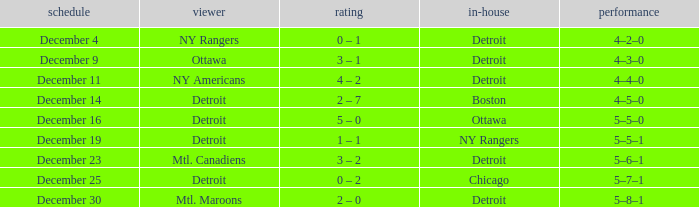What visitor has December 14 as the date? Detroit. 